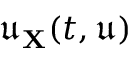Convert formula to latex. <formula><loc_0><loc_0><loc_500><loc_500>\mathfrak { u } _ { X } ( t , \mathfrak { u } )</formula> 